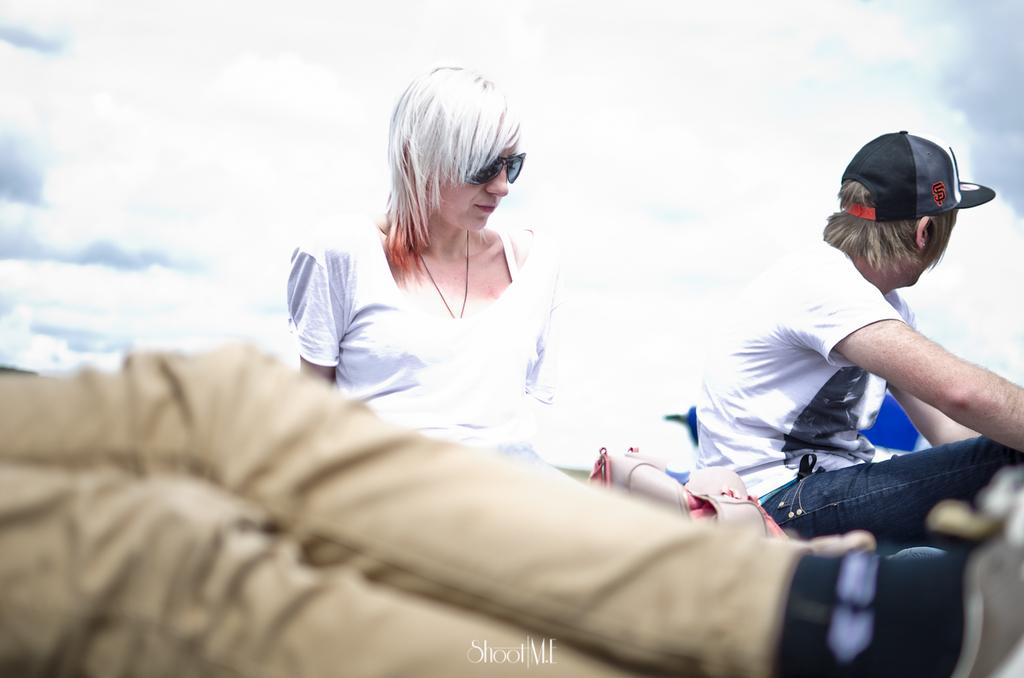Who or what can be seen in the image? There are people in the image. What can be seen in the distance or background of the image? The sky is visible in the background of the image. Is there any text or writing present in the image? Yes, there is text at the bottom of the image. What type of sugar is being traded by the people in the image? There is no mention of sugar or trading in the image; it only shows people and text at the bottom. 